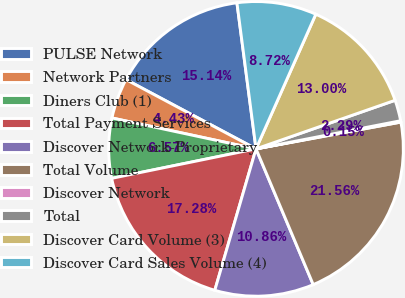Convert chart. <chart><loc_0><loc_0><loc_500><loc_500><pie_chart><fcel>PULSE Network<fcel>Network Partners<fcel>Diners Club (1)<fcel>Total Payment Services<fcel>Discover Network-Proprietary<fcel>Total Volume<fcel>Discover Network<fcel>Total<fcel>Discover Card Volume (3)<fcel>Discover Card Sales Volume (4)<nl><fcel>15.14%<fcel>4.43%<fcel>6.57%<fcel>17.28%<fcel>10.86%<fcel>21.56%<fcel>0.15%<fcel>2.29%<fcel>13.0%<fcel>8.72%<nl></chart> 